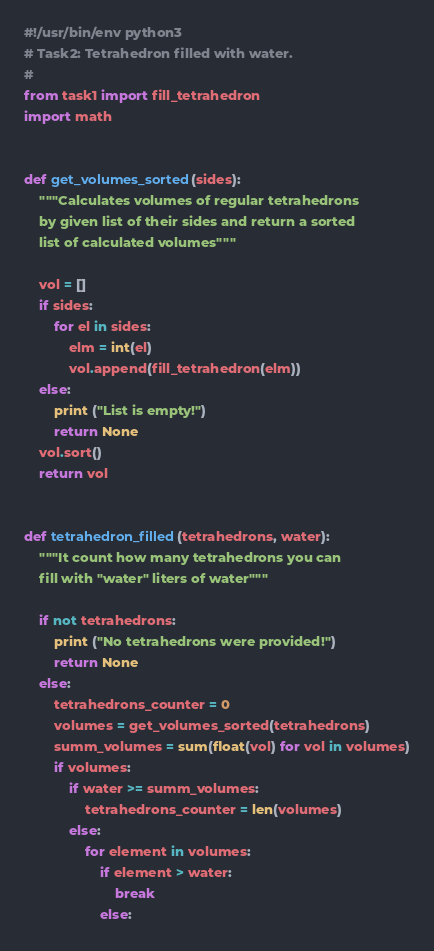<code> <loc_0><loc_0><loc_500><loc_500><_Python_>#!/usr/bin/env python3
# Task2: Tetrahedron filled with water.
#
from task1 import fill_tetrahedron
import math


def get_volumes_sorted(sides):
    """Calculates volumes of regular tetrahedrons
    by given list of their sides and return a sorted
    list of calculated volumes"""

    vol = []
    if sides:
        for el in sides:
            elm = int(el)
            vol.append(fill_tetrahedron(elm))
    else:
        print ("List is empty!")
        return None
    vol.sort()
    return vol


def tetrahedron_filled(tetrahedrons, water):
    """It count how many tetrahedrons you can 
    fill with "water" liters of water"""

    if not tetrahedrons:
        print ("No tetrahedrons were provided!")
        return None
    else:
        tetrahedrons_counter = 0
        volumes = get_volumes_sorted(tetrahedrons)
        summ_volumes = sum(float(vol) for vol in volumes)
        if volumes:
            if water >= summ_volumes:
                tetrahedrons_counter = len(volumes)
            else:
                for element in volumes:
                    if element > water:
                        break
                    else:</code> 